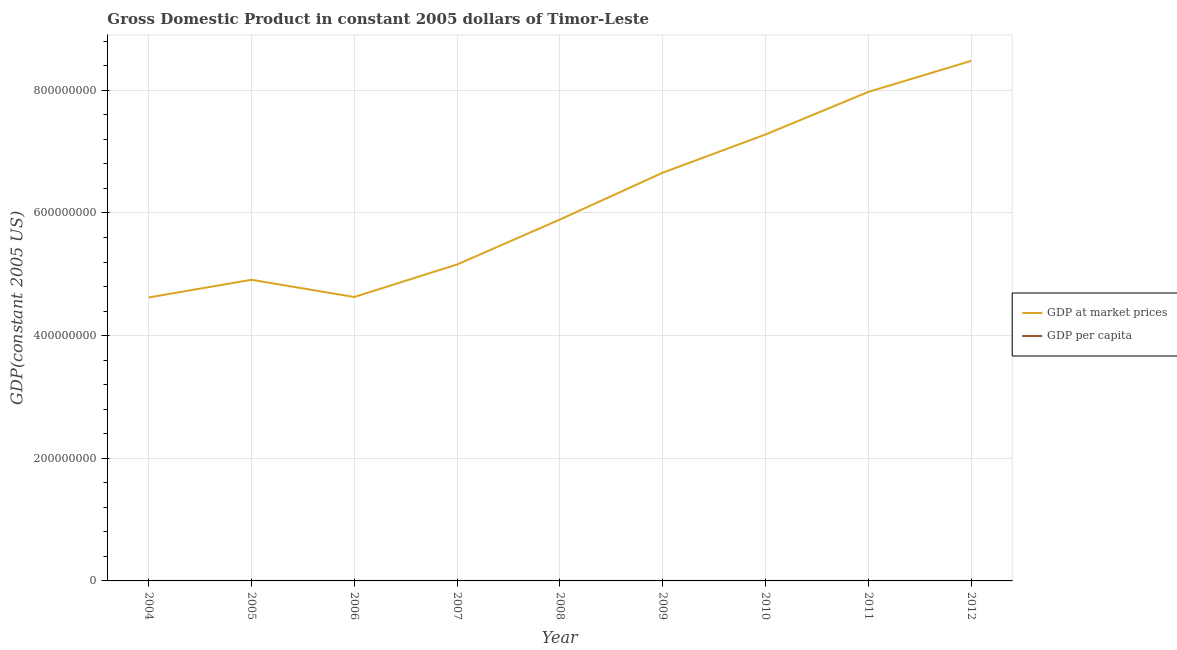How many different coloured lines are there?
Your answer should be compact. 2. Does the line corresponding to gdp at market prices intersect with the line corresponding to gdp per capita?
Offer a terse response. No. Is the number of lines equal to the number of legend labels?
Your response must be concise. Yes. What is the gdp per capita in 2010?
Offer a terse response. 682.6. Across all years, what is the maximum gdp at market prices?
Ensure brevity in your answer.  8.48e+08. Across all years, what is the minimum gdp at market prices?
Give a very brief answer. 4.62e+08. In which year was the gdp per capita maximum?
Your answer should be very brief. 2012. What is the total gdp at market prices in the graph?
Make the answer very short. 5.56e+09. What is the difference between the gdp per capita in 2004 and that in 2008?
Your answer should be compact. -91.59. What is the difference between the gdp per capita in 2006 and the gdp at market prices in 2009?
Give a very brief answer. -6.66e+08. What is the average gdp per capita per year?
Offer a very short reply. 588.26. In the year 2010, what is the difference between the gdp per capita and gdp at market prices?
Ensure brevity in your answer.  -7.28e+08. In how many years, is the gdp per capita greater than 160000000 US$?
Offer a very short reply. 0. What is the ratio of the gdp per capita in 2006 to that in 2008?
Your answer should be compact. 0.81. Is the gdp per capita in 2011 less than that in 2012?
Provide a short and direct response. Yes. What is the difference between the highest and the second highest gdp per capita?
Ensure brevity in your answer.  26.4. What is the difference between the highest and the lowest gdp at market prices?
Your answer should be compact. 3.86e+08. In how many years, is the gdp at market prices greater than the average gdp at market prices taken over all years?
Provide a succinct answer. 4. Where does the legend appear in the graph?
Give a very brief answer. Center right. How many legend labels are there?
Your answer should be very brief. 2. What is the title of the graph?
Provide a short and direct response. Gross Domestic Product in constant 2005 dollars of Timor-Leste. What is the label or title of the Y-axis?
Your answer should be very brief. GDP(constant 2005 US). What is the GDP(constant 2005 US) in GDP at market prices in 2004?
Keep it short and to the point. 4.62e+08. What is the GDP(constant 2005 US) of GDP per capita in 2004?
Provide a succinct answer. 480.1. What is the GDP(constant 2005 US) of GDP at market prices in 2005?
Keep it short and to the point. 4.91e+08. What is the GDP(constant 2005 US) of GDP per capita in 2005?
Make the answer very short. 501.43. What is the GDP(constant 2005 US) of GDP at market prices in 2006?
Your answer should be compact. 4.63e+08. What is the GDP(constant 2005 US) in GDP per capita in 2006?
Offer a very short reply. 464.78. What is the GDP(constant 2005 US) of GDP at market prices in 2007?
Your answer should be compact. 5.16e+08. What is the GDP(constant 2005 US) of GDP per capita in 2007?
Provide a short and direct response. 509.22. What is the GDP(constant 2005 US) in GDP at market prices in 2008?
Make the answer very short. 5.89e+08. What is the GDP(constant 2005 US) of GDP per capita in 2008?
Provide a short and direct response. 571.69. What is the GDP(constant 2005 US) in GDP at market prices in 2009?
Make the answer very short. 6.66e+08. What is the GDP(constant 2005 US) in GDP per capita in 2009?
Give a very brief answer. 634.87. What is the GDP(constant 2005 US) in GDP at market prices in 2010?
Provide a succinct answer. 7.28e+08. What is the GDP(constant 2005 US) in GDP per capita in 2010?
Give a very brief answer. 682.6. What is the GDP(constant 2005 US) in GDP at market prices in 2011?
Make the answer very short. 7.97e+08. What is the GDP(constant 2005 US) of GDP per capita in 2011?
Give a very brief answer. 711.62. What is the GDP(constant 2005 US) of GDP at market prices in 2012?
Make the answer very short. 8.48e+08. What is the GDP(constant 2005 US) in GDP per capita in 2012?
Make the answer very short. 738.02. Across all years, what is the maximum GDP(constant 2005 US) of GDP at market prices?
Your answer should be very brief. 8.48e+08. Across all years, what is the maximum GDP(constant 2005 US) in GDP per capita?
Your answer should be very brief. 738.02. Across all years, what is the minimum GDP(constant 2005 US) in GDP at market prices?
Provide a succinct answer. 4.62e+08. Across all years, what is the minimum GDP(constant 2005 US) of GDP per capita?
Your response must be concise. 464.78. What is the total GDP(constant 2005 US) in GDP at market prices in the graph?
Your answer should be very brief. 5.56e+09. What is the total GDP(constant 2005 US) of GDP per capita in the graph?
Ensure brevity in your answer.  5294.32. What is the difference between the GDP(constant 2005 US) in GDP at market prices in 2004 and that in 2005?
Keep it short and to the point. -2.88e+07. What is the difference between the GDP(constant 2005 US) of GDP per capita in 2004 and that in 2005?
Your answer should be compact. -21.33. What is the difference between the GDP(constant 2005 US) in GDP at market prices in 2004 and that in 2006?
Make the answer very short. -7.79e+05. What is the difference between the GDP(constant 2005 US) of GDP per capita in 2004 and that in 2006?
Make the answer very short. 15.33. What is the difference between the GDP(constant 2005 US) in GDP at market prices in 2004 and that in 2007?
Your response must be concise. -5.38e+07. What is the difference between the GDP(constant 2005 US) of GDP per capita in 2004 and that in 2007?
Offer a very short reply. -29.12. What is the difference between the GDP(constant 2005 US) of GDP at market prices in 2004 and that in 2008?
Make the answer very short. -1.27e+08. What is the difference between the GDP(constant 2005 US) in GDP per capita in 2004 and that in 2008?
Ensure brevity in your answer.  -91.59. What is the difference between the GDP(constant 2005 US) of GDP at market prices in 2004 and that in 2009?
Offer a terse response. -2.03e+08. What is the difference between the GDP(constant 2005 US) of GDP per capita in 2004 and that in 2009?
Ensure brevity in your answer.  -154.77. What is the difference between the GDP(constant 2005 US) in GDP at market prices in 2004 and that in 2010?
Offer a very short reply. -2.66e+08. What is the difference between the GDP(constant 2005 US) of GDP per capita in 2004 and that in 2010?
Ensure brevity in your answer.  -202.49. What is the difference between the GDP(constant 2005 US) in GDP at market prices in 2004 and that in 2011?
Your response must be concise. -3.35e+08. What is the difference between the GDP(constant 2005 US) in GDP per capita in 2004 and that in 2011?
Offer a very short reply. -231.51. What is the difference between the GDP(constant 2005 US) in GDP at market prices in 2004 and that in 2012?
Your answer should be compact. -3.86e+08. What is the difference between the GDP(constant 2005 US) of GDP per capita in 2004 and that in 2012?
Provide a short and direct response. -257.91. What is the difference between the GDP(constant 2005 US) of GDP at market prices in 2005 and that in 2006?
Ensure brevity in your answer.  2.81e+07. What is the difference between the GDP(constant 2005 US) in GDP per capita in 2005 and that in 2006?
Provide a succinct answer. 36.65. What is the difference between the GDP(constant 2005 US) in GDP at market prices in 2005 and that in 2007?
Provide a short and direct response. -2.49e+07. What is the difference between the GDP(constant 2005 US) in GDP per capita in 2005 and that in 2007?
Keep it short and to the point. -7.79. What is the difference between the GDP(constant 2005 US) in GDP at market prices in 2005 and that in 2008?
Your answer should be very brief. -9.82e+07. What is the difference between the GDP(constant 2005 US) of GDP per capita in 2005 and that in 2008?
Provide a short and direct response. -70.26. What is the difference between the GDP(constant 2005 US) of GDP at market prices in 2005 and that in 2009?
Ensure brevity in your answer.  -1.75e+08. What is the difference between the GDP(constant 2005 US) in GDP per capita in 2005 and that in 2009?
Provide a short and direct response. -133.44. What is the difference between the GDP(constant 2005 US) of GDP at market prices in 2005 and that in 2010?
Give a very brief answer. -2.37e+08. What is the difference between the GDP(constant 2005 US) in GDP per capita in 2005 and that in 2010?
Provide a short and direct response. -181.17. What is the difference between the GDP(constant 2005 US) of GDP at market prices in 2005 and that in 2011?
Make the answer very short. -3.06e+08. What is the difference between the GDP(constant 2005 US) of GDP per capita in 2005 and that in 2011?
Make the answer very short. -210.19. What is the difference between the GDP(constant 2005 US) in GDP at market prices in 2005 and that in 2012?
Offer a terse response. -3.57e+08. What is the difference between the GDP(constant 2005 US) of GDP per capita in 2005 and that in 2012?
Your answer should be compact. -236.59. What is the difference between the GDP(constant 2005 US) of GDP at market prices in 2006 and that in 2007?
Ensure brevity in your answer.  -5.30e+07. What is the difference between the GDP(constant 2005 US) of GDP per capita in 2006 and that in 2007?
Offer a very short reply. -44.44. What is the difference between the GDP(constant 2005 US) of GDP at market prices in 2006 and that in 2008?
Ensure brevity in your answer.  -1.26e+08. What is the difference between the GDP(constant 2005 US) in GDP per capita in 2006 and that in 2008?
Your answer should be very brief. -106.91. What is the difference between the GDP(constant 2005 US) in GDP at market prices in 2006 and that in 2009?
Give a very brief answer. -2.03e+08. What is the difference between the GDP(constant 2005 US) of GDP per capita in 2006 and that in 2009?
Offer a terse response. -170.09. What is the difference between the GDP(constant 2005 US) of GDP at market prices in 2006 and that in 2010?
Your answer should be compact. -2.65e+08. What is the difference between the GDP(constant 2005 US) of GDP per capita in 2006 and that in 2010?
Offer a very short reply. -217.82. What is the difference between the GDP(constant 2005 US) in GDP at market prices in 2006 and that in 2011?
Provide a short and direct response. -3.34e+08. What is the difference between the GDP(constant 2005 US) in GDP per capita in 2006 and that in 2011?
Your answer should be very brief. -246.84. What is the difference between the GDP(constant 2005 US) of GDP at market prices in 2006 and that in 2012?
Offer a terse response. -3.85e+08. What is the difference between the GDP(constant 2005 US) in GDP per capita in 2006 and that in 2012?
Offer a very short reply. -273.24. What is the difference between the GDP(constant 2005 US) in GDP at market prices in 2007 and that in 2008?
Make the answer very short. -7.33e+07. What is the difference between the GDP(constant 2005 US) in GDP per capita in 2007 and that in 2008?
Make the answer very short. -62.47. What is the difference between the GDP(constant 2005 US) of GDP at market prices in 2007 and that in 2009?
Give a very brief answer. -1.50e+08. What is the difference between the GDP(constant 2005 US) of GDP per capita in 2007 and that in 2009?
Your answer should be very brief. -125.65. What is the difference between the GDP(constant 2005 US) in GDP at market prices in 2007 and that in 2010?
Provide a short and direct response. -2.12e+08. What is the difference between the GDP(constant 2005 US) of GDP per capita in 2007 and that in 2010?
Offer a very short reply. -173.38. What is the difference between the GDP(constant 2005 US) in GDP at market prices in 2007 and that in 2011?
Keep it short and to the point. -2.81e+08. What is the difference between the GDP(constant 2005 US) in GDP per capita in 2007 and that in 2011?
Offer a terse response. -202.4. What is the difference between the GDP(constant 2005 US) in GDP at market prices in 2007 and that in 2012?
Your answer should be compact. -3.32e+08. What is the difference between the GDP(constant 2005 US) of GDP per capita in 2007 and that in 2012?
Offer a very short reply. -228.79. What is the difference between the GDP(constant 2005 US) of GDP at market prices in 2008 and that in 2009?
Offer a terse response. -7.64e+07. What is the difference between the GDP(constant 2005 US) of GDP per capita in 2008 and that in 2009?
Your answer should be compact. -63.18. What is the difference between the GDP(constant 2005 US) of GDP at market prices in 2008 and that in 2010?
Provide a short and direct response. -1.39e+08. What is the difference between the GDP(constant 2005 US) of GDP per capita in 2008 and that in 2010?
Give a very brief answer. -110.91. What is the difference between the GDP(constant 2005 US) of GDP at market prices in 2008 and that in 2011?
Offer a terse response. -2.08e+08. What is the difference between the GDP(constant 2005 US) of GDP per capita in 2008 and that in 2011?
Provide a short and direct response. -139.93. What is the difference between the GDP(constant 2005 US) of GDP at market prices in 2008 and that in 2012?
Keep it short and to the point. -2.59e+08. What is the difference between the GDP(constant 2005 US) of GDP per capita in 2008 and that in 2012?
Offer a terse response. -166.33. What is the difference between the GDP(constant 2005 US) in GDP at market prices in 2009 and that in 2010?
Your response must be concise. -6.23e+07. What is the difference between the GDP(constant 2005 US) of GDP per capita in 2009 and that in 2010?
Keep it short and to the point. -47.73. What is the difference between the GDP(constant 2005 US) of GDP at market prices in 2009 and that in 2011?
Offer a terse response. -1.32e+08. What is the difference between the GDP(constant 2005 US) of GDP per capita in 2009 and that in 2011?
Offer a very short reply. -76.75. What is the difference between the GDP(constant 2005 US) in GDP at market prices in 2009 and that in 2012?
Offer a terse response. -1.82e+08. What is the difference between the GDP(constant 2005 US) of GDP per capita in 2009 and that in 2012?
Provide a short and direct response. -103.14. What is the difference between the GDP(constant 2005 US) of GDP at market prices in 2010 and that in 2011?
Give a very brief answer. -6.94e+07. What is the difference between the GDP(constant 2005 US) in GDP per capita in 2010 and that in 2011?
Make the answer very short. -29.02. What is the difference between the GDP(constant 2005 US) in GDP at market prices in 2010 and that in 2012?
Offer a terse response. -1.20e+08. What is the difference between the GDP(constant 2005 US) in GDP per capita in 2010 and that in 2012?
Provide a succinct answer. -55.42. What is the difference between the GDP(constant 2005 US) in GDP at market prices in 2011 and that in 2012?
Your answer should be compact. -5.07e+07. What is the difference between the GDP(constant 2005 US) of GDP per capita in 2011 and that in 2012?
Offer a very short reply. -26.4. What is the difference between the GDP(constant 2005 US) in GDP at market prices in 2004 and the GDP(constant 2005 US) in GDP per capita in 2005?
Ensure brevity in your answer.  4.62e+08. What is the difference between the GDP(constant 2005 US) in GDP at market prices in 2004 and the GDP(constant 2005 US) in GDP per capita in 2006?
Your answer should be compact. 4.62e+08. What is the difference between the GDP(constant 2005 US) in GDP at market prices in 2004 and the GDP(constant 2005 US) in GDP per capita in 2007?
Your answer should be very brief. 4.62e+08. What is the difference between the GDP(constant 2005 US) of GDP at market prices in 2004 and the GDP(constant 2005 US) of GDP per capita in 2008?
Keep it short and to the point. 4.62e+08. What is the difference between the GDP(constant 2005 US) in GDP at market prices in 2004 and the GDP(constant 2005 US) in GDP per capita in 2009?
Make the answer very short. 4.62e+08. What is the difference between the GDP(constant 2005 US) in GDP at market prices in 2004 and the GDP(constant 2005 US) in GDP per capita in 2010?
Ensure brevity in your answer.  4.62e+08. What is the difference between the GDP(constant 2005 US) of GDP at market prices in 2004 and the GDP(constant 2005 US) of GDP per capita in 2011?
Your answer should be very brief. 4.62e+08. What is the difference between the GDP(constant 2005 US) in GDP at market prices in 2004 and the GDP(constant 2005 US) in GDP per capita in 2012?
Make the answer very short. 4.62e+08. What is the difference between the GDP(constant 2005 US) in GDP at market prices in 2005 and the GDP(constant 2005 US) in GDP per capita in 2006?
Your answer should be compact. 4.91e+08. What is the difference between the GDP(constant 2005 US) of GDP at market prices in 2005 and the GDP(constant 2005 US) of GDP per capita in 2007?
Offer a very short reply. 4.91e+08. What is the difference between the GDP(constant 2005 US) of GDP at market prices in 2005 and the GDP(constant 2005 US) of GDP per capita in 2008?
Give a very brief answer. 4.91e+08. What is the difference between the GDP(constant 2005 US) of GDP at market prices in 2005 and the GDP(constant 2005 US) of GDP per capita in 2009?
Give a very brief answer. 4.91e+08. What is the difference between the GDP(constant 2005 US) of GDP at market prices in 2005 and the GDP(constant 2005 US) of GDP per capita in 2010?
Your answer should be very brief. 4.91e+08. What is the difference between the GDP(constant 2005 US) of GDP at market prices in 2005 and the GDP(constant 2005 US) of GDP per capita in 2011?
Keep it short and to the point. 4.91e+08. What is the difference between the GDP(constant 2005 US) of GDP at market prices in 2005 and the GDP(constant 2005 US) of GDP per capita in 2012?
Your answer should be very brief. 4.91e+08. What is the difference between the GDP(constant 2005 US) in GDP at market prices in 2006 and the GDP(constant 2005 US) in GDP per capita in 2007?
Your response must be concise. 4.63e+08. What is the difference between the GDP(constant 2005 US) in GDP at market prices in 2006 and the GDP(constant 2005 US) in GDP per capita in 2008?
Your response must be concise. 4.63e+08. What is the difference between the GDP(constant 2005 US) in GDP at market prices in 2006 and the GDP(constant 2005 US) in GDP per capita in 2009?
Your answer should be compact. 4.63e+08. What is the difference between the GDP(constant 2005 US) of GDP at market prices in 2006 and the GDP(constant 2005 US) of GDP per capita in 2010?
Provide a short and direct response. 4.63e+08. What is the difference between the GDP(constant 2005 US) in GDP at market prices in 2006 and the GDP(constant 2005 US) in GDP per capita in 2011?
Your response must be concise. 4.63e+08. What is the difference between the GDP(constant 2005 US) in GDP at market prices in 2006 and the GDP(constant 2005 US) in GDP per capita in 2012?
Ensure brevity in your answer.  4.63e+08. What is the difference between the GDP(constant 2005 US) of GDP at market prices in 2007 and the GDP(constant 2005 US) of GDP per capita in 2008?
Your answer should be very brief. 5.16e+08. What is the difference between the GDP(constant 2005 US) of GDP at market prices in 2007 and the GDP(constant 2005 US) of GDP per capita in 2009?
Offer a very short reply. 5.16e+08. What is the difference between the GDP(constant 2005 US) in GDP at market prices in 2007 and the GDP(constant 2005 US) in GDP per capita in 2010?
Make the answer very short. 5.16e+08. What is the difference between the GDP(constant 2005 US) of GDP at market prices in 2007 and the GDP(constant 2005 US) of GDP per capita in 2011?
Offer a very short reply. 5.16e+08. What is the difference between the GDP(constant 2005 US) in GDP at market prices in 2007 and the GDP(constant 2005 US) in GDP per capita in 2012?
Provide a short and direct response. 5.16e+08. What is the difference between the GDP(constant 2005 US) in GDP at market prices in 2008 and the GDP(constant 2005 US) in GDP per capita in 2009?
Make the answer very short. 5.89e+08. What is the difference between the GDP(constant 2005 US) in GDP at market prices in 2008 and the GDP(constant 2005 US) in GDP per capita in 2010?
Make the answer very short. 5.89e+08. What is the difference between the GDP(constant 2005 US) in GDP at market prices in 2008 and the GDP(constant 2005 US) in GDP per capita in 2011?
Provide a short and direct response. 5.89e+08. What is the difference between the GDP(constant 2005 US) of GDP at market prices in 2008 and the GDP(constant 2005 US) of GDP per capita in 2012?
Offer a terse response. 5.89e+08. What is the difference between the GDP(constant 2005 US) in GDP at market prices in 2009 and the GDP(constant 2005 US) in GDP per capita in 2010?
Offer a very short reply. 6.66e+08. What is the difference between the GDP(constant 2005 US) in GDP at market prices in 2009 and the GDP(constant 2005 US) in GDP per capita in 2011?
Provide a succinct answer. 6.66e+08. What is the difference between the GDP(constant 2005 US) in GDP at market prices in 2009 and the GDP(constant 2005 US) in GDP per capita in 2012?
Make the answer very short. 6.66e+08. What is the difference between the GDP(constant 2005 US) of GDP at market prices in 2010 and the GDP(constant 2005 US) of GDP per capita in 2011?
Make the answer very short. 7.28e+08. What is the difference between the GDP(constant 2005 US) of GDP at market prices in 2010 and the GDP(constant 2005 US) of GDP per capita in 2012?
Make the answer very short. 7.28e+08. What is the difference between the GDP(constant 2005 US) in GDP at market prices in 2011 and the GDP(constant 2005 US) in GDP per capita in 2012?
Your answer should be very brief. 7.97e+08. What is the average GDP(constant 2005 US) in GDP at market prices per year?
Keep it short and to the point. 6.18e+08. What is the average GDP(constant 2005 US) in GDP per capita per year?
Offer a very short reply. 588.26. In the year 2004, what is the difference between the GDP(constant 2005 US) in GDP at market prices and GDP(constant 2005 US) in GDP per capita?
Provide a succinct answer. 4.62e+08. In the year 2005, what is the difference between the GDP(constant 2005 US) in GDP at market prices and GDP(constant 2005 US) in GDP per capita?
Give a very brief answer. 4.91e+08. In the year 2006, what is the difference between the GDP(constant 2005 US) of GDP at market prices and GDP(constant 2005 US) of GDP per capita?
Your answer should be very brief. 4.63e+08. In the year 2007, what is the difference between the GDP(constant 2005 US) of GDP at market prices and GDP(constant 2005 US) of GDP per capita?
Make the answer very short. 5.16e+08. In the year 2008, what is the difference between the GDP(constant 2005 US) of GDP at market prices and GDP(constant 2005 US) of GDP per capita?
Offer a very short reply. 5.89e+08. In the year 2009, what is the difference between the GDP(constant 2005 US) in GDP at market prices and GDP(constant 2005 US) in GDP per capita?
Ensure brevity in your answer.  6.66e+08. In the year 2010, what is the difference between the GDP(constant 2005 US) of GDP at market prices and GDP(constant 2005 US) of GDP per capita?
Your answer should be very brief. 7.28e+08. In the year 2011, what is the difference between the GDP(constant 2005 US) of GDP at market prices and GDP(constant 2005 US) of GDP per capita?
Keep it short and to the point. 7.97e+08. In the year 2012, what is the difference between the GDP(constant 2005 US) in GDP at market prices and GDP(constant 2005 US) in GDP per capita?
Give a very brief answer. 8.48e+08. What is the ratio of the GDP(constant 2005 US) of GDP at market prices in 2004 to that in 2005?
Provide a succinct answer. 0.94. What is the ratio of the GDP(constant 2005 US) of GDP per capita in 2004 to that in 2005?
Provide a short and direct response. 0.96. What is the ratio of the GDP(constant 2005 US) in GDP per capita in 2004 to that in 2006?
Keep it short and to the point. 1.03. What is the ratio of the GDP(constant 2005 US) of GDP at market prices in 2004 to that in 2007?
Your answer should be compact. 0.9. What is the ratio of the GDP(constant 2005 US) in GDP per capita in 2004 to that in 2007?
Offer a very short reply. 0.94. What is the ratio of the GDP(constant 2005 US) of GDP at market prices in 2004 to that in 2008?
Ensure brevity in your answer.  0.78. What is the ratio of the GDP(constant 2005 US) in GDP per capita in 2004 to that in 2008?
Your answer should be very brief. 0.84. What is the ratio of the GDP(constant 2005 US) in GDP at market prices in 2004 to that in 2009?
Make the answer very short. 0.69. What is the ratio of the GDP(constant 2005 US) of GDP per capita in 2004 to that in 2009?
Your answer should be compact. 0.76. What is the ratio of the GDP(constant 2005 US) in GDP at market prices in 2004 to that in 2010?
Offer a very short reply. 0.63. What is the ratio of the GDP(constant 2005 US) in GDP per capita in 2004 to that in 2010?
Offer a terse response. 0.7. What is the ratio of the GDP(constant 2005 US) of GDP at market prices in 2004 to that in 2011?
Provide a short and direct response. 0.58. What is the ratio of the GDP(constant 2005 US) in GDP per capita in 2004 to that in 2011?
Your answer should be compact. 0.67. What is the ratio of the GDP(constant 2005 US) of GDP at market prices in 2004 to that in 2012?
Give a very brief answer. 0.55. What is the ratio of the GDP(constant 2005 US) of GDP per capita in 2004 to that in 2012?
Offer a very short reply. 0.65. What is the ratio of the GDP(constant 2005 US) in GDP at market prices in 2005 to that in 2006?
Offer a very short reply. 1.06. What is the ratio of the GDP(constant 2005 US) of GDP per capita in 2005 to that in 2006?
Provide a short and direct response. 1.08. What is the ratio of the GDP(constant 2005 US) of GDP at market prices in 2005 to that in 2007?
Your answer should be compact. 0.95. What is the ratio of the GDP(constant 2005 US) of GDP per capita in 2005 to that in 2007?
Make the answer very short. 0.98. What is the ratio of the GDP(constant 2005 US) in GDP per capita in 2005 to that in 2008?
Your response must be concise. 0.88. What is the ratio of the GDP(constant 2005 US) in GDP at market prices in 2005 to that in 2009?
Your answer should be compact. 0.74. What is the ratio of the GDP(constant 2005 US) in GDP per capita in 2005 to that in 2009?
Keep it short and to the point. 0.79. What is the ratio of the GDP(constant 2005 US) in GDP at market prices in 2005 to that in 2010?
Your response must be concise. 0.67. What is the ratio of the GDP(constant 2005 US) in GDP per capita in 2005 to that in 2010?
Make the answer very short. 0.73. What is the ratio of the GDP(constant 2005 US) in GDP at market prices in 2005 to that in 2011?
Give a very brief answer. 0.62. What is the ratio of the GDP(constant 2005 US) of GDP per capita in 2005 to that in 2011?
Your response must be concise. 0.7. What is the ratio of the GDP(constant 2005 US) in GDP at market prices in 2005 to that in 2012?
Offer a very short reply. 0.58. What is the ratio of the GDP(constant 2005 US) of GDP per capita in 2005 to that in 2012?
Make the answer very short. 0.68. What is the ratio of the GDP(constant 2005 US) in GDP at market prices in 2006 to that in 2007?
Offer a very short reply. 0.9. What is the ratio of the GDP(constant 2005 US) in GDP per capita in 2006 to that in 2007?
Give a very brief answer. 0.91. What is the ratio of the GDP(constant 2005 US) in GDP at market prices in 2006 to that in 2008?
Offer a terse response. 0.79. What is the ratio of the GDP(constant 2005 US) of GDP per capita in 2006 to that in 2008?
Offer a very short reply. 0.81. What is the ratio of the GDP(constant 2005 US) in GDP at market prices in 2006 to that in 2009?
Offer a terse response. 0.7. What is the ratio of the GDP(constant 2005 US) of GDP per capita in 2006 to that in 2009?
Keep it short and to the point. 0.73. What is the ratio of the GDP(constant 2005 US) in GDP at market prices in 2006 to that in 2010?
Your answer should be compact. 0.64. What is the ratio of the GDP(constant 2005 US) in GDP per capita in 2006 to that in 2010?
Provide a succinct answer. 0.68. What is the ratio of the GDP(constant 2005 US) of GDP at market prices in 2006 to that in 2011?
Provide a succinct answer. 0.58. What is the ratio of the GDP(constant 2005 US) of GDP per capita in 2006 to that in 2011?
Offer a very short reply. 0.65. What is the ratio of the GDP(constant 2005 US) in GDP at market prices in 2006 to that in 2012?
Provide a succinct answer. 0.55. What is the ratio of the GDP(constant 2005 US) of GDP per capita in 2006 to that in 2012?
Offer a terse response. 0.63. What is the ratio of the GDP(constant 2005 US) of GDP at market prices in 2007 to that in 2008?
Offer a very short reply. 0.88. What is the ratio of the GDP(constant 2005 US) of GDP per capita in 2007 to that in 2008?
Offer a very short reply. 0.89. What is the ratio of the GDP(constant 2005 US) in GDP at market prices in 2007 to that in 2009?
Give a very brief answer. 0.78. What is the ratio of the GDP(constant 2005 US) of GDP per capita in 2007 to that in 2009?
Provide a succinct answer. 0.8. What is the ratio of the GDP(constant 2005 US) in GDP at market prices in 2007 to that in 2010?
Offer a terse response. 0.71. What is the ratio of the GDP(constant 2005 US) in GDP per capita in 2007 to that in 2010?
Provide a short and direct response. 0.75. What is the ratio of the GDP(constant 2005 US) of GDP at market prices in 2007 to that in 2011?
Your answer should be compact. 0.65. What is the ratio of the GDP(constant 2005 US) in GDP per capita in 2007 to that in 2011?
Give a very brief answer. 0.72. What is the ratio of the GDP(constant 2005 US) of GDP at market prices in 2007 to that in 2012?
Your answer should be compact. 0.61. What is the ratio of the GDP(constant 2005 US) in GDP per capita in 2007 to that in 2012?
Your response must be concise. 0.69. What is the ratio of the GDP(constant 2005 US) of GDP at market prices in 2008 to that in 2009?
Provide a succinct answer. 0.89. What is the ratio of the GDP(constant 2005 US) in GDP per capita in 2008 to that in 2009?
Offer a terse response. 0.9. What is the ratio of the GDP(constant 2005 US) in GDP at market prices in 2008 to that in 2010?
Provide a short and direct response. 0.81. What is the ratio of the GDP(constant 2005 US) of GDP per capita in 2008 to that in 2010?
Make the answer very short. 0.84. What is the ratio of the GDP(constant 2005 US) of GDP at market prices in 2008 to that in 2011?
Provide a short and direct response. 0.74. What is the ratio of the GDP(constant 2005 US) in GDP per capita in 2008 to that in 2011?
Your answer should be compact. 0.8. What is the ratio of the GDP(constant 2005 US) in GDP at market prices in 2008 to that in 2012?
Ensure brevity in your answer.  0.69. What is the ratio of the GDP(constant 2005 US) in GDP per capita in 2008 to that in 2012?
Make the answer very short. 0.77. What is the ratio of the GDP(constant 2005 US) in GDP at market prices in 2009 to that in 2010?
Keep it short and to the point. 0.91. What is the ratio of the GDP(constant 2005 US) in GDP per capita in 2009 to that in 2010?
Make the answer very short. 0.93. What is the ratio of the GDP(constant 2005 US) in GDP at market prices in 2009 to that in 2011?
Your answer should be compact. 0.83. What is the ratio of the GDP(constant 2005 US) in GDP per capita in 2009 to that in 2011?
Your answer should be compact. 0.89. What is the ratio of the GDP(constant 2005 US) of GDP at market prices in 2009 to that in 2012?
Keep it short and to the point. 0.78. What is the ratio of the GDP(constant 2005 US) in GDP per capita in 2009 to that in 2012?
Ensure brevity in your answer.  0.86. What is the ratio of the GDP(constant 2005 US) in GDP per capita in 2010 to that in 2011?
Provide a succinct answer. 0.96. What is the ratio of the GDP(constant 2005 US) in GDP at market prices in 2010 to that in 2012?
Offer a terse response. 0.86. What is the ratio of the GDP(constant 2005 US) in GDP per capita in 2010 to that in 2012?
Make the answer very short. 0.92. What is the ratio of the GDP(constant 2005 US) in GDP at market prices in 2011 to that in 2012?
Make the answer very short. 0.94. What is the ratio of the GDP(constant 2005 US) of GDP per capita in 2011 to that in 2012?
Keep it short and to the point. 0.96. What is the difference between the highest and the second highest GDP(constant 2005 US) in GDP at market prices?
Give a very brief answer. 5.07e+07. What is the difference between the highest and the second highest GDP(constant 2005 US) of GDP per capita?
Keep it short and to the point. 26.4. What is the difference between the highest and the lowest GDP(constant 2005 US) of GDP at market prices?
Give a very brief answer. 3.86e+08. What is the difference between the highest and the lowest GDP(constant 2005 US) in GDP per capita?
Provide a short and direct response. 273.24. 